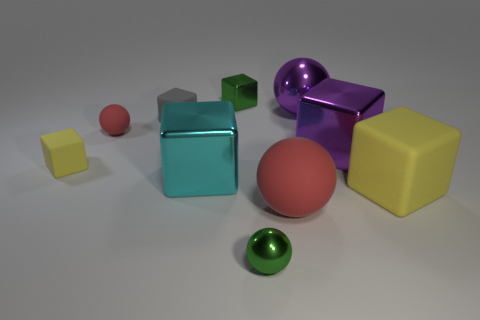There is a big red object that is made of the same material as the gray block; what shape is it?
Offer a terse response. Sphere. There is a tiny green object that is behind the small yellow block; does it have the same shape as the big cyan shiny thing that is in front of the tiny green metal block?
Your answer should be very brief. Yes. Are there fewer cyan cubes in front of the green metal ball than objects in front of the tiny metallic cube?
Provide a short and direct response. Yes. There is a large matte object that is the same color as the tiny matte sphere; what is its shape?
Offer a very short reply. Sphere. What number of shiny blocks are the same size as the purple shiny sphere?
Provide a short and direct response. 2. Is the red thing to the left of the small gray rubber object made of the same material as the tiny yellow cube?
Keep it short and to the point. Yes. Are any blue cubes visible?
Your answer should be compact. No. There is a red ball that is the same material as the tiny red thing; what size is it?
Provide a short and direct response. Large. Are there any small metal things of the same color as the tiny matte ball?
Ensure brevity in your answer.  No. Does the metallic ball in front of the purple shiny block have the same color as the small shiny object that is behind the tiny red matte thing?
Your answer should be very brief. Yes. 